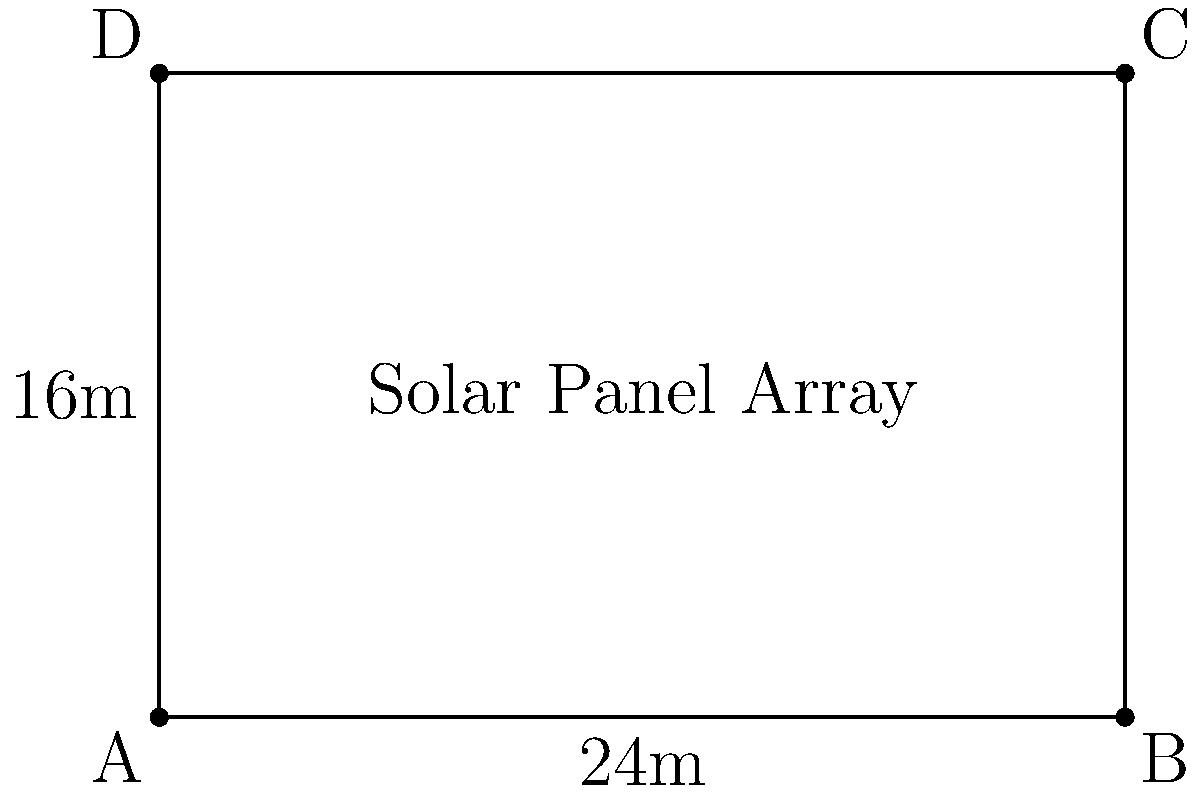An eco-lodge is planning to install a rectangular solar panel array to power its facilities. The array measures 24 meters in length and 16 meters in width. Calculate the total area of the solar panel array in square meters. To calculate the area of a rectangular solar panel array, we need to multiply its length by its width. Let's follow these steps:

1. Identify the given dimensions:
   Length ($l$) = 24 meters
   Width ($w$) = 16 meters

2. Use the formula for the area of a rectangle:
   $A = l \times w$

3. Substitute the values into the formula:
   $A = 24 \text{ m} \times 16 \text{ m}$

4. Perform the multiplication:
   $A = 384 \text{ m}^2$

Therefore, the total area of the solar panel array is 384 square meters.
Answer: $384 \text{ m}^2$ 